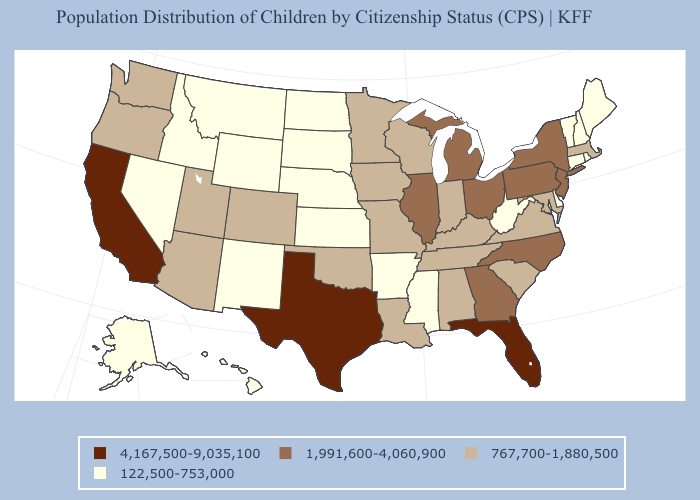Does Texas have the highest value in the USA?
Quick response, please. Yes. Name the states that have a value in the range 1,991,600-4,060,900?
Answer briefly. Georgia, Illinois, Michigan, New Jersey, New York, North Carolina, Ohio, Pennsylvania. Among the states that border North Carolina , which have the highest value?
Write a very short answer. Georgia. Does Kansas have the highest value in the MidWest?
Be succinct. No. What is the lowest value in the West?
Answer briefly. 122,500-753,000. What is the value of South Carolina?
Be succinct. 767,700-1,880,500. Among the states that border Virginia , which have the highest value?
Answer briefly. North Carolina. What is the value of Arizona?
Keep it brief. 767,700-1,880,500. Among the states that border Wyoming , which have the lowest value?
Give a very brief answer. Idaho, Montana, Nebraska, South Dakota. Does Ohio have a higher value than New Mexico?
Concise answer only. Yes. Name the states that have a value in the range 1,991,600-4,060,900?
Be succinct. Georgia, Illinois, Michigan, New Jersey, New York, North Carolina, Ohio, Pennsylvania. Which states have the lowest value in the USA?
Quick response, please. Alaska, Arkansas, Connecticut, Delaware, Hawaii, Idaho, Kansas, Maine, Mississippi, Montana, Nebraska, Nevada, New Hampshire, New Mexico, North Dakota, Rhode Island, South Dakota, Vermont, West Virginia, Wyoming. What is the value of North Dakota?
Be succinct. 122,500-753,000. Name the states that have a value in the range 122,500-753,000?
Be succinct. Alaska, Arkansas, Connecticut, Delaware, Hawaii, Idaho, Kansas, Maine, Mississippi, Montana, Nebraska, Nevada, New Hampshire, New Mexico, North Dakota, Rhode Island, South Dakota, Vermont, West Virginia, Wyoming. 